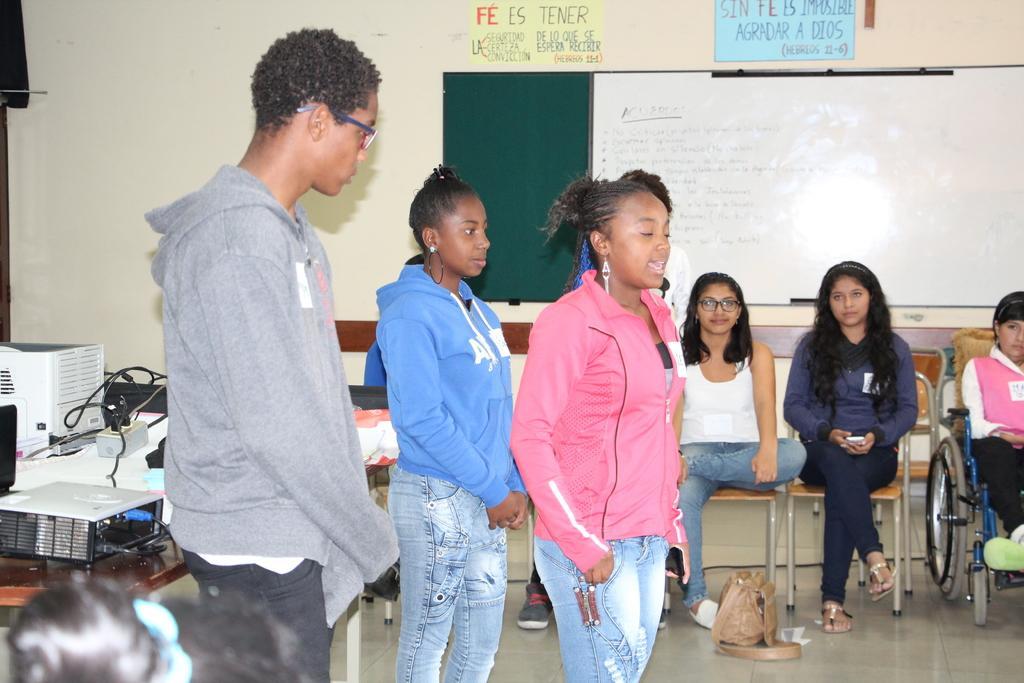Describe this image in one or two sentences. This picture shows few people are standing and few are seated on the chairs and we see a girl seated on the wheelchair and we see a white board and couple of posters on the wall and we see a projector on the table and we see a handbag on the floor. 